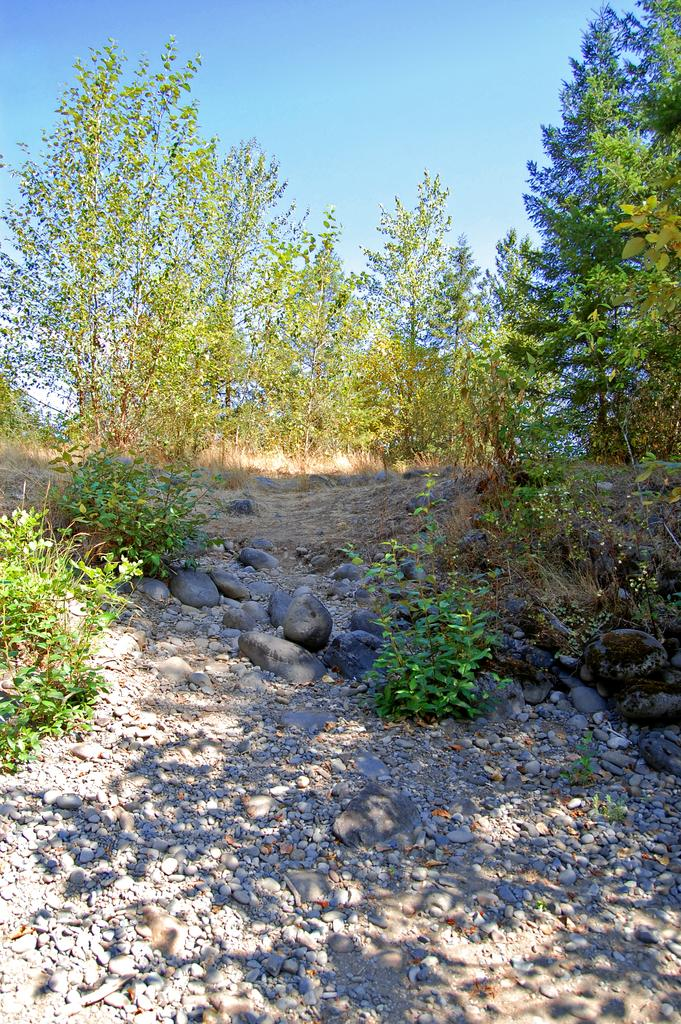What type of vegetation is present in the image? There are many trees and plants in the image. What other natural elements can be seen in the image? There are stones and sand in the image. Is there a wound visible on any of the trees in the image? There is no indication of a wound on any of the trees in the image. Can you see a volcano erupting in the background of the image? There is no volcano present in the image. 